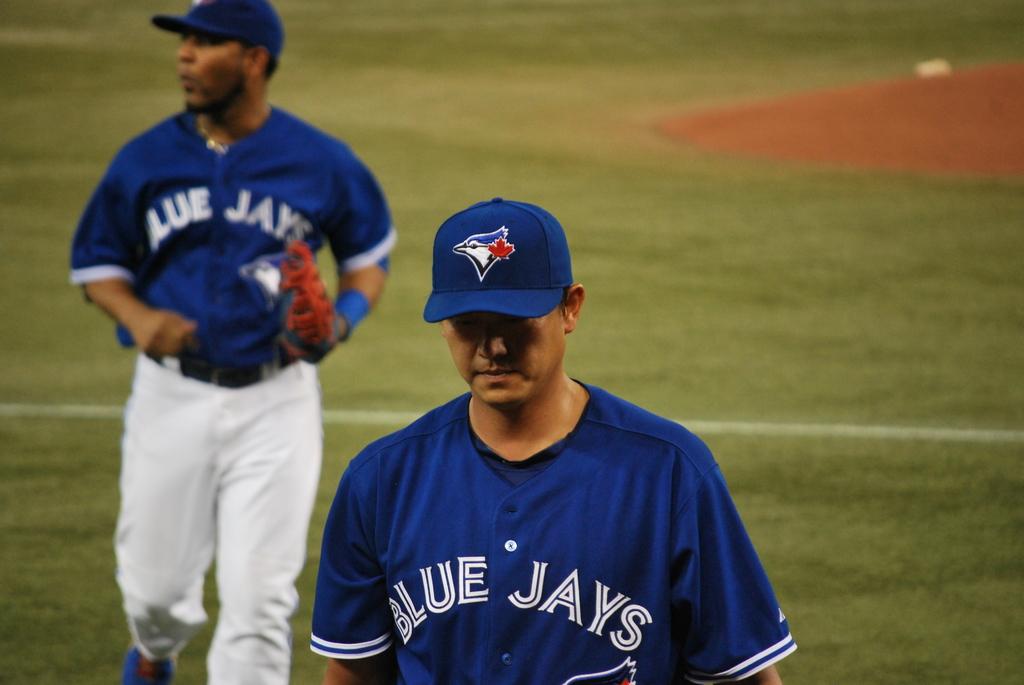What is the team name on the jerseys shown?
Your answer should be compact. Blue jays. 